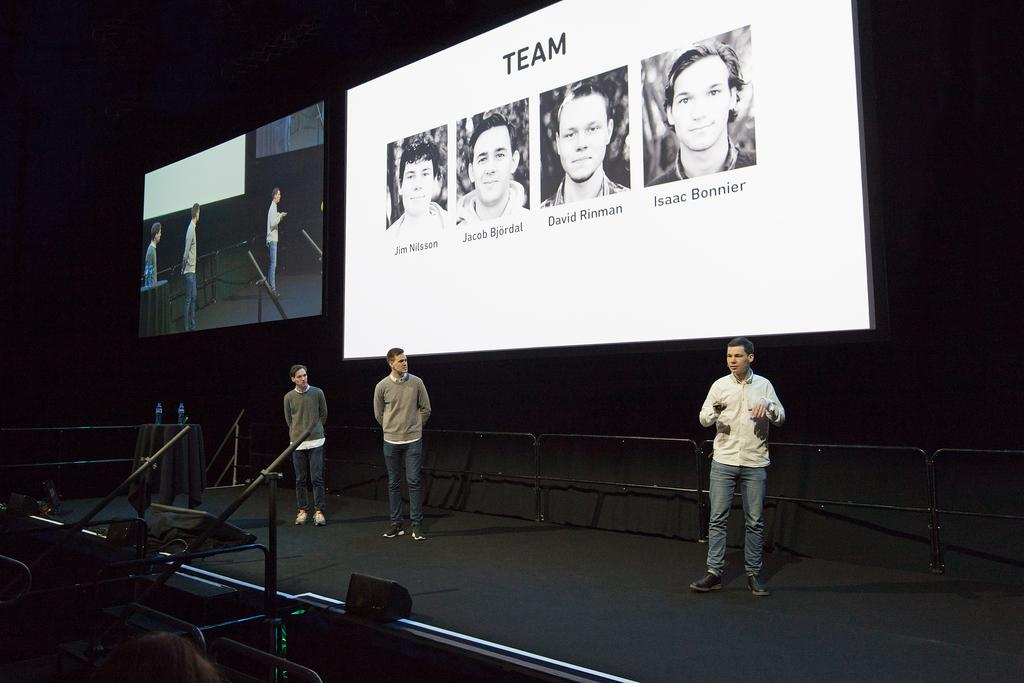What is happening in the image? There are people standing on a stage in the image. What can be seen behind the stage? There are two display screens visible behind the stage. What type of produce is being displayed on the stage in the image? There is no produce visible in the image; it features people standing on a stage and display screens behind the stage. 